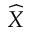<formula> <loc_0><loc_0><loc_500><loc_500>\widehat { X }</formula> 